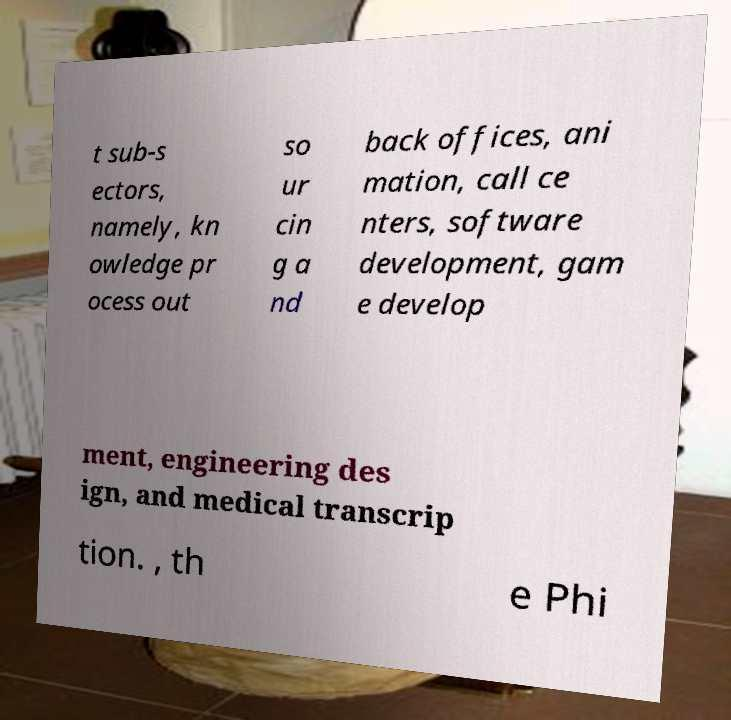For documentation purposes, I need the text within this image transcribed. Could you provide that? t sub-s ectors, namely, kn owledge pr ocess out so ur cin g a nd back offices, ani mation, call ce nters, software development, gam e develop ment, engineering des ign, and medical transcrip tion. , th e Phi 